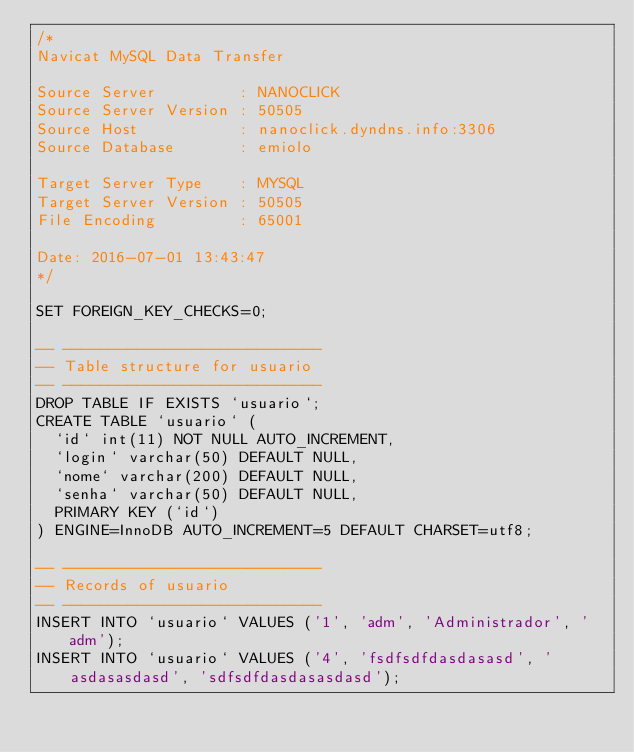<code> <loc_0><loc_0><loc_500><loc_500><_SQL_>/*
Navicat MySQL Data Transfer

Source Server         : NANOCLICK
Source Server Version : 50505
Source Host           : nanoclick.dyndns.info:3306
Source Database       : emiolo

Target Server Type    : MYSQL
Target Server Version : 50505
File Encoding         : 65001

Date: 2016-07-01 13:43:47
*/

SET FOREIGN_KEY_CHECKS=0;

-- ----------------------------
-- Table structure for usuario
-- ----------------------------
DROP TABLE IF EXISTS `usuario`;
CREATE TABLE `usuario` (
  `id` int(11) NOT NULL AUTO_INCREMENT,
  `login` varchar(50) DEFAULT NULL,
  `nome` varchar(200) DEFAULT NULL,
  `senha` varchar(50) DEFAULT NULL,
  PRIMARY KEY (`id`)
) ENGINE=InnoDB AUTO_INCREMENT=5 DEFAULT CHARSET=utf8;

-- ----------------------------
-- Records of usuario
-- ----------------------------
INSERT INTO `usuario` VALUES ('1', 'adm', 'Administrador', 'adm');
INSERT INTO `usuario` VALUES ('4', 'fsdfsdfdasdasasd', 'asdasasdasd', 'sdfsdfdasdasasdasd');
</code> 